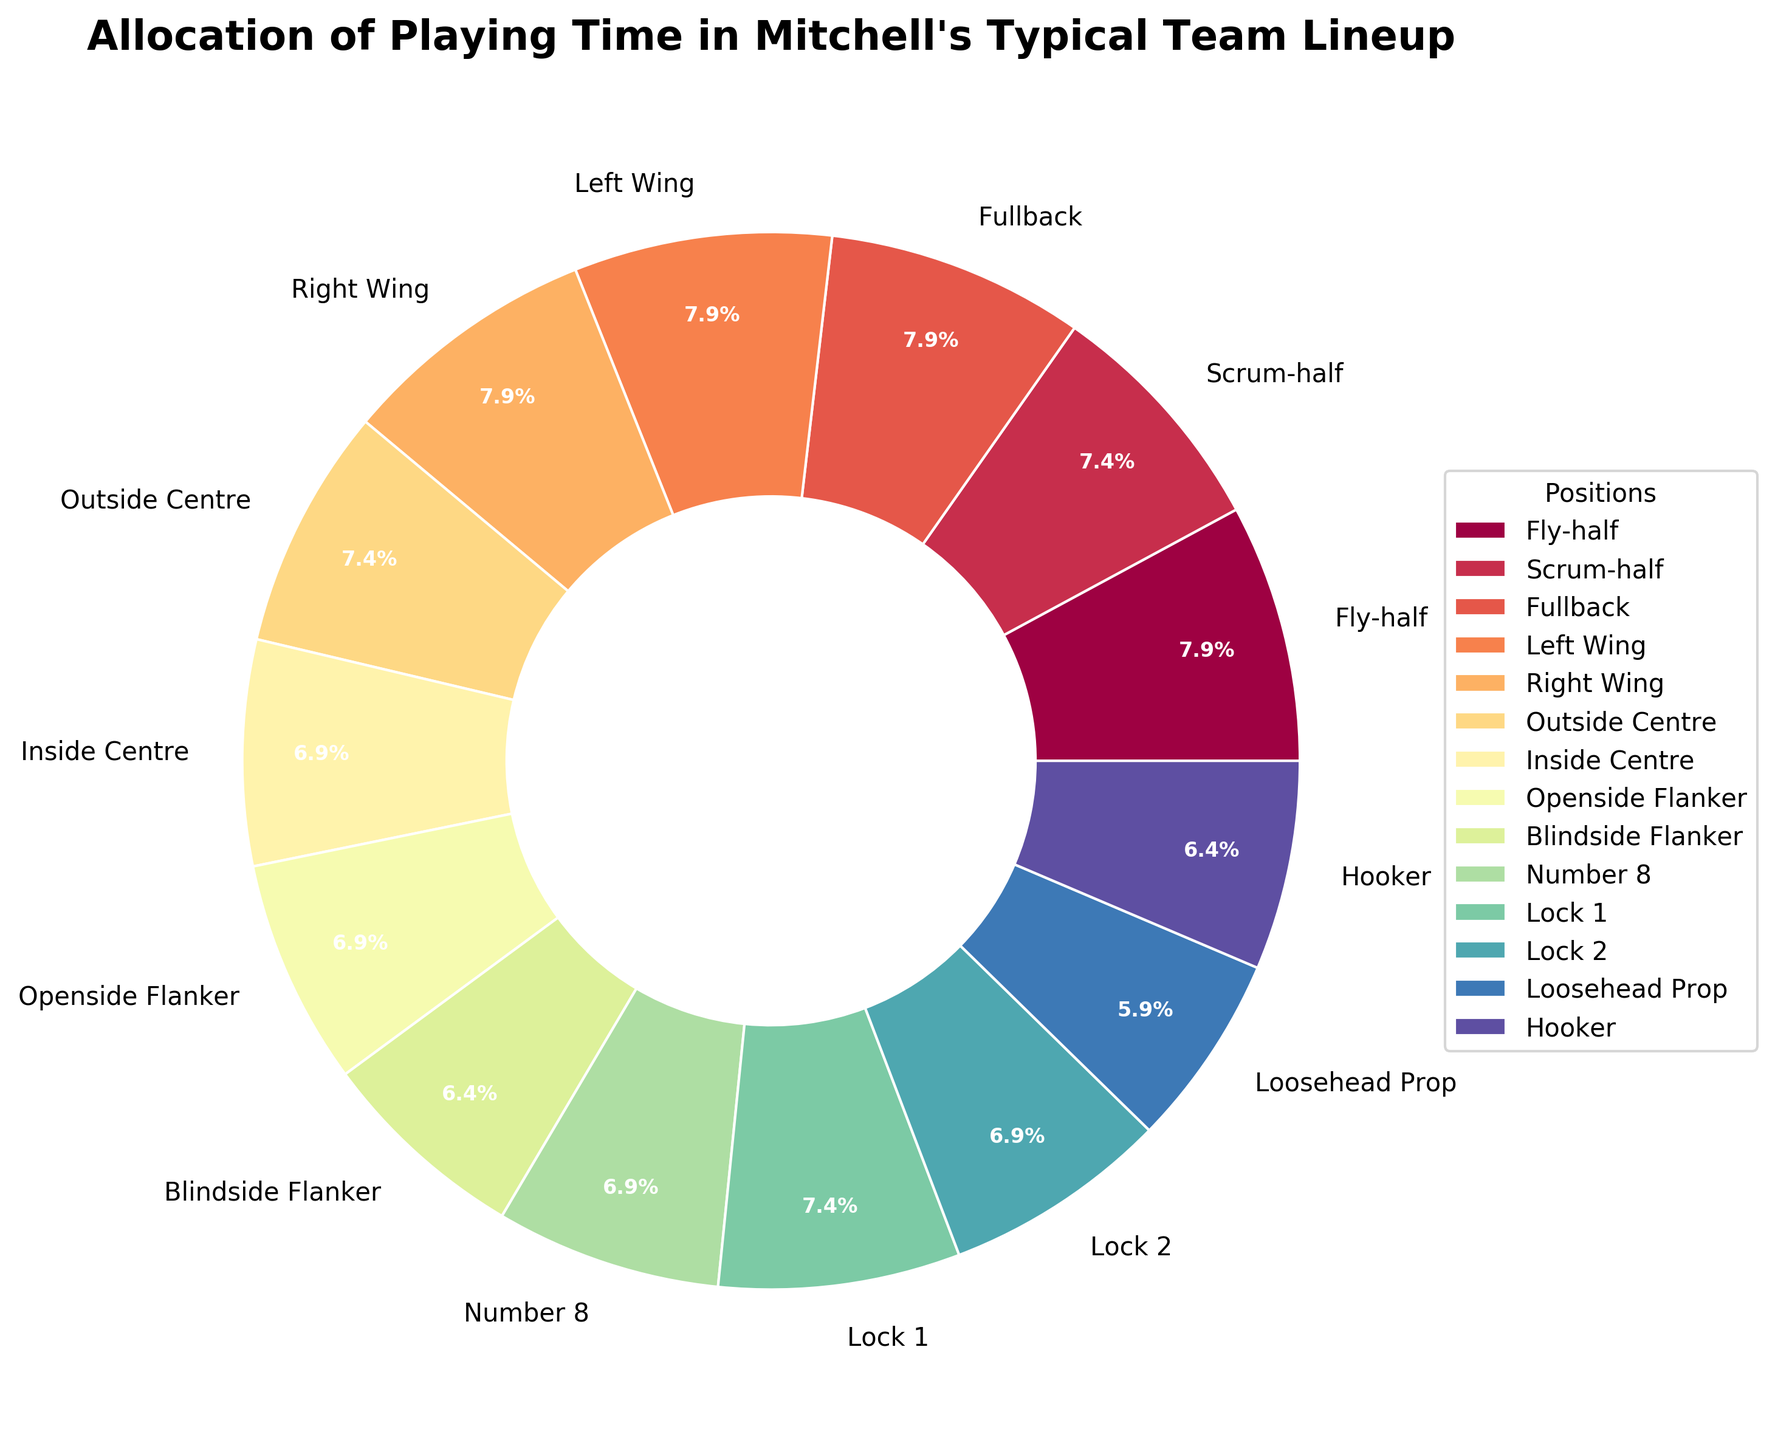What position has the highest percentage of playing time? First, look at the pie chart and identify the position with the largest wedge. In this case, the Fly-half, Fullback, Left Wing, and Right Wing each have a wedge marked with 13.1%, which is the highest percentage.
Answer: Fly-half, Fullback, Left Wing, Right Wing Which positions have equal playing time allocation? Look for wedges with the same percentage label. Fly-half, Fullback, Left Wing, and Right Wing all have 13.1% each. Scrum-half, Outside Centre, and Lock 1 have 12.3% each.
Answer: Fly-half, Fullback, Left Wing, Right Wing; Scrum-half, Outside Centre, Lock 1 What is the total playing time percentage for the Fly-half and Scrum-half combined? Add the percentages for Fly-half and Scrum-half together: 13.1% (Fly-half) + 12.3% (Scrum-half) = 25.4%.
Answer: 25.4% Which position has the least playing time and what percentage is it? Examine the smallest wedge in the pie chart for the least playing time, which is the Tighthead Prop with 5.5%.
Answer: Tighthead Prop, 5.5% How does the playing time for the Fullback compare to the Inside Centre? Compare the percentage labels for both positions: Fullback has 13.1%, while Inside Centre has 11.5%. Fullback has a higher percentage than Inside Centre.
Answer: Fullback > Inside Centre What is the difference in playing time percentage between the Openside Flanker and Blindside Flanker? Subtract the percentage of Blindside Flanker from the Openside Flanker: 11.5% (Openside Flanker) - 10.7% (Blindside Flanker) = 0.8%.
Answer: 0.8% What is the combined percentage of playing time for all the Replacement positions shown? Sum up the percentages for the replacement positions: 
Replacement Fly-half (1.6%) + Replacement Scrum-half (0.8%) + Replacement Back (2.5%) + Replacement Flanker (2.5%) + Replacement Prop (4.1%) = 11.5%.
Answer: 11.5% Which positions share an identical color hue, indicating a similar amount of playing time? Positions with similar amounts of playing time are represented by similar hues. Fly-half, Fullback, Left Wing, and Right Wing all share similar hues as they each have 13.1% playing time. Scrum-half, Outside Centre, and Lock 1 also share similar hues with 12.3% playing time each.
Answer: Fly-half, Fullback, Left Wing, Right Wing; Scrum-half, Outside Centre, Lock 1 